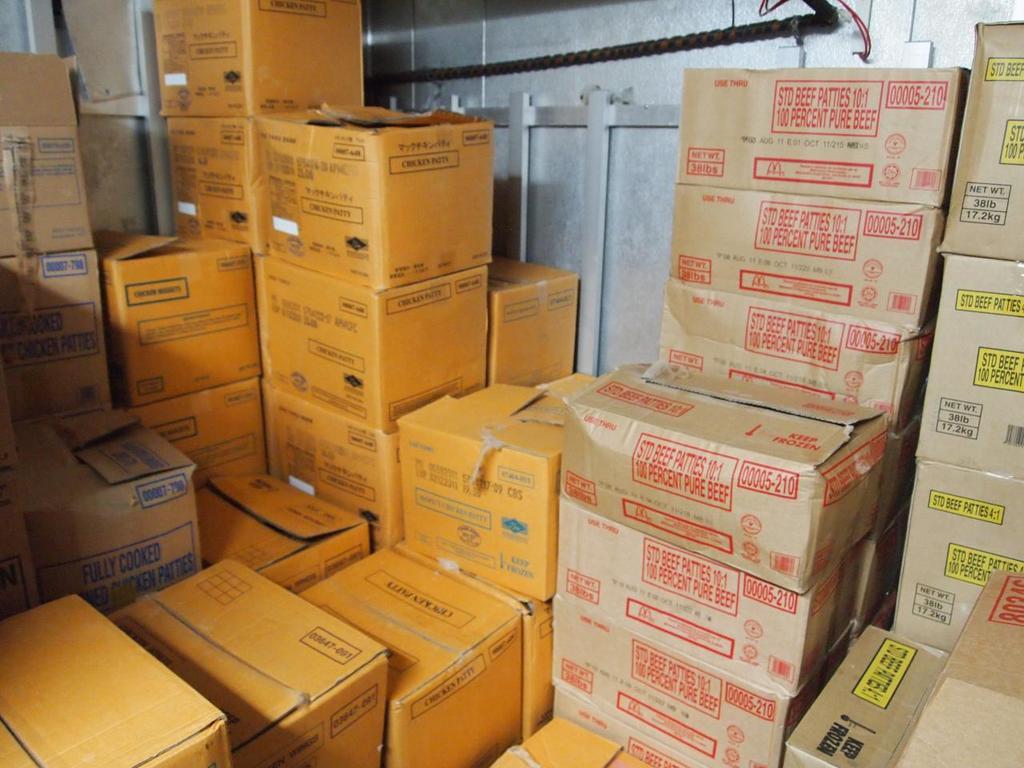Do the boxes need to be kept frozen?
Your answer should be compact. Yes. 